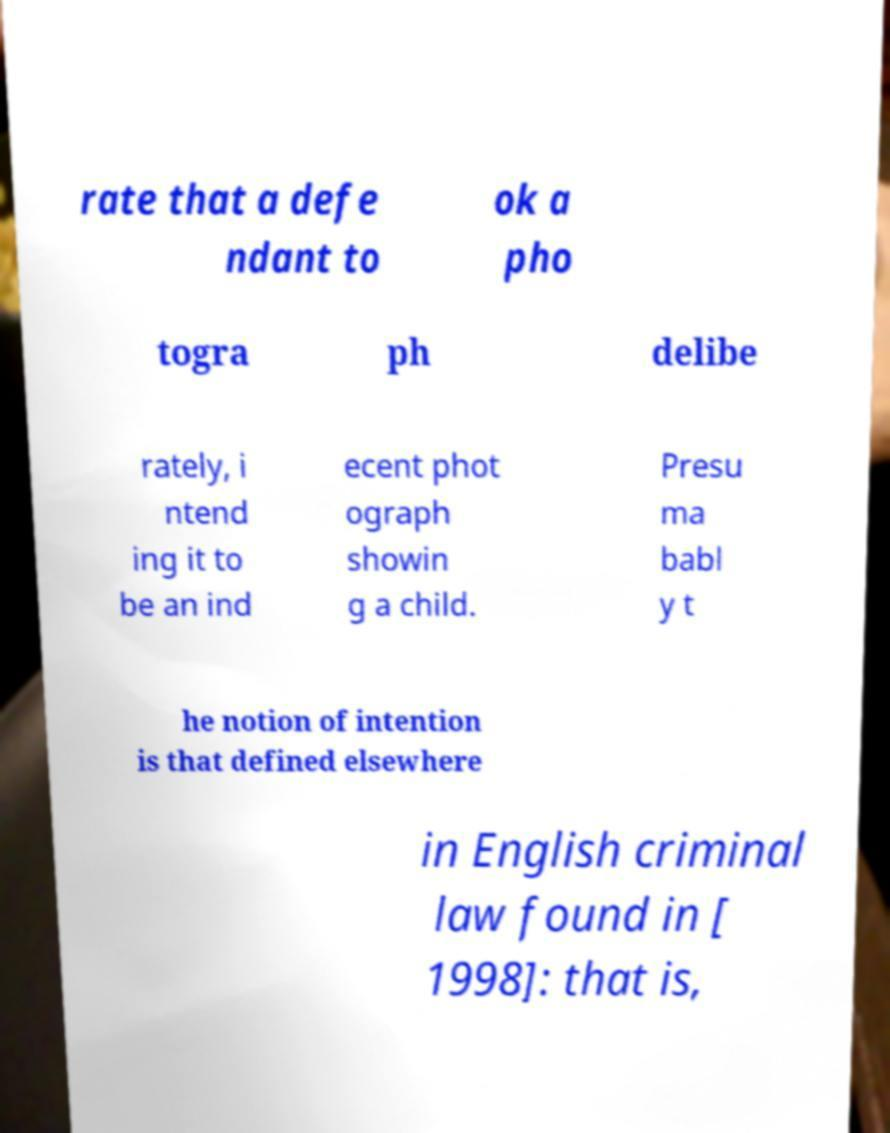There's text embedded in this image that I need extracted. Can you transcribe it verbatim? rate that a defe ndant to ok a pho togra ph delibe rately, i ntend ing it to be an ind ecent phot ograph showin g a child. Presu ma babl y t he notion of intention is that defined elsewhere in English criminal law found in [ 1998]: that is, 